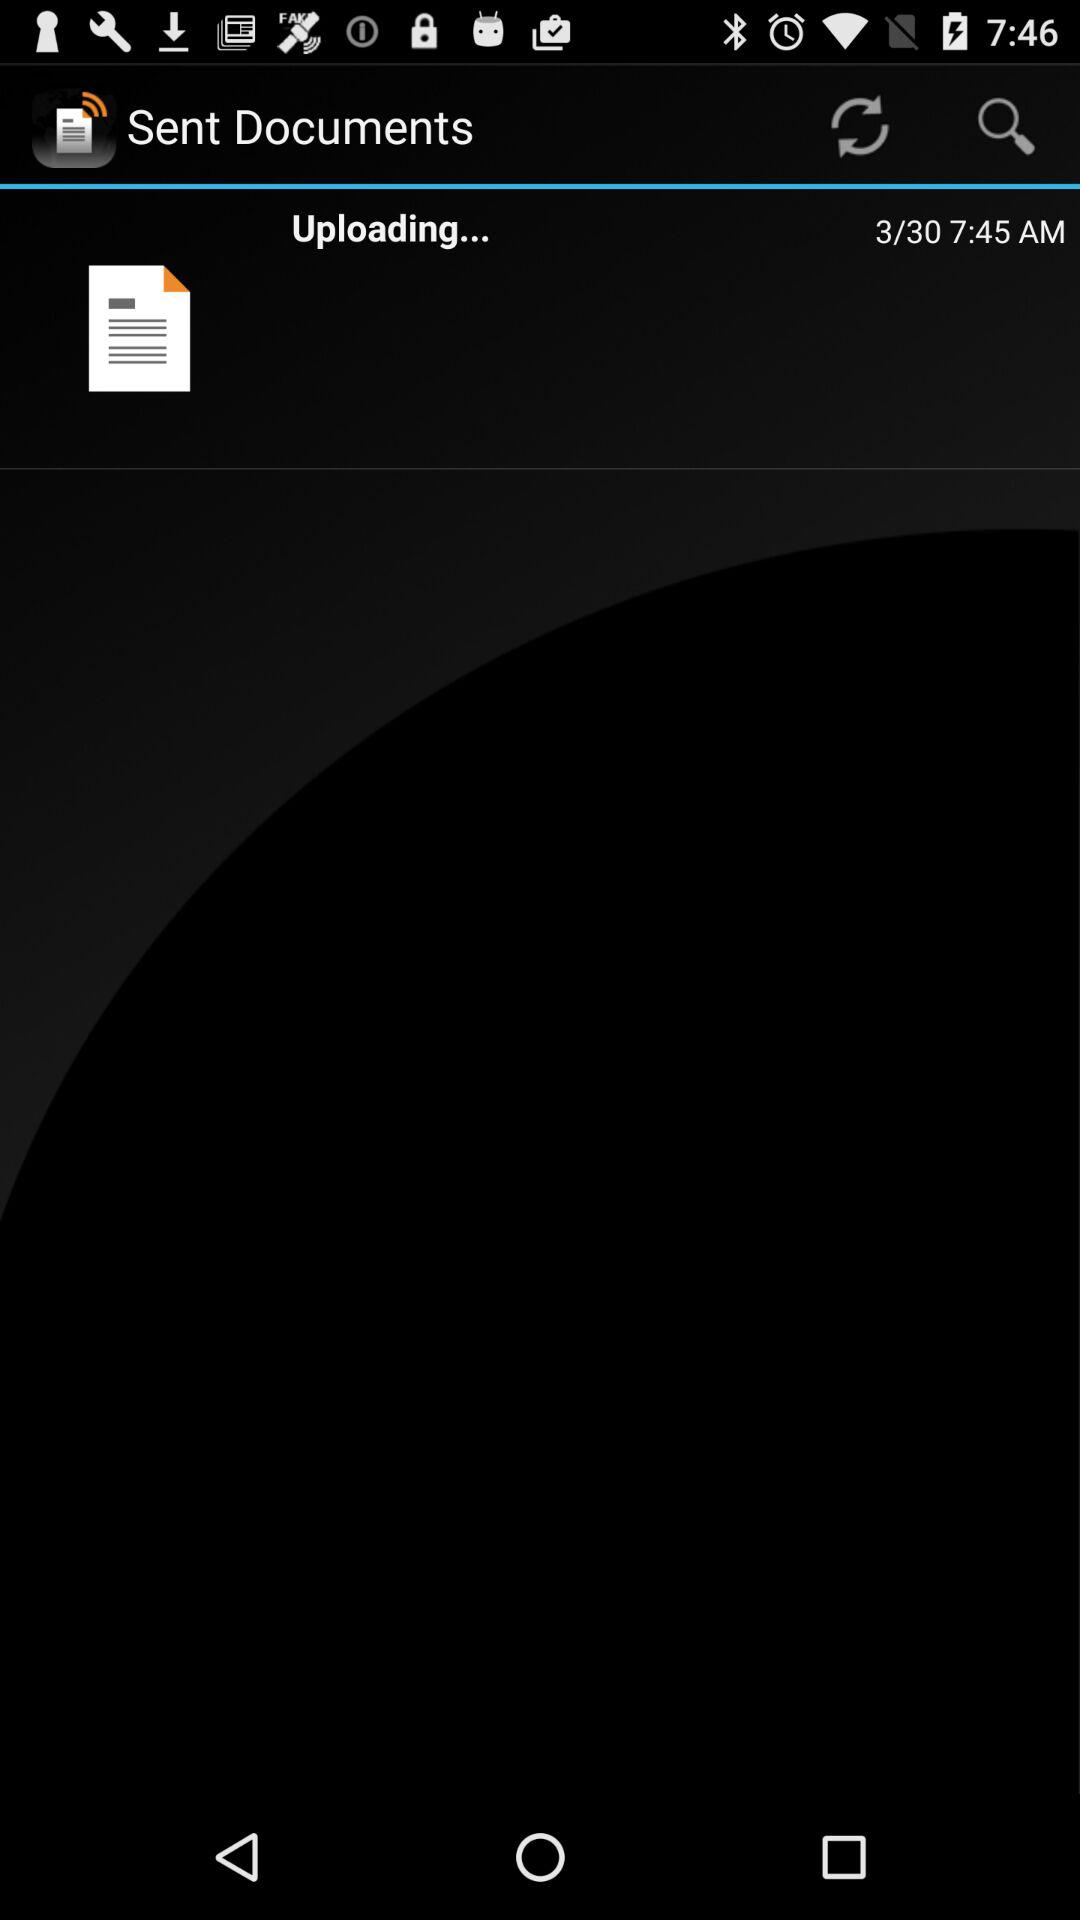On what date was the document sent? The document was sent on March 30. 